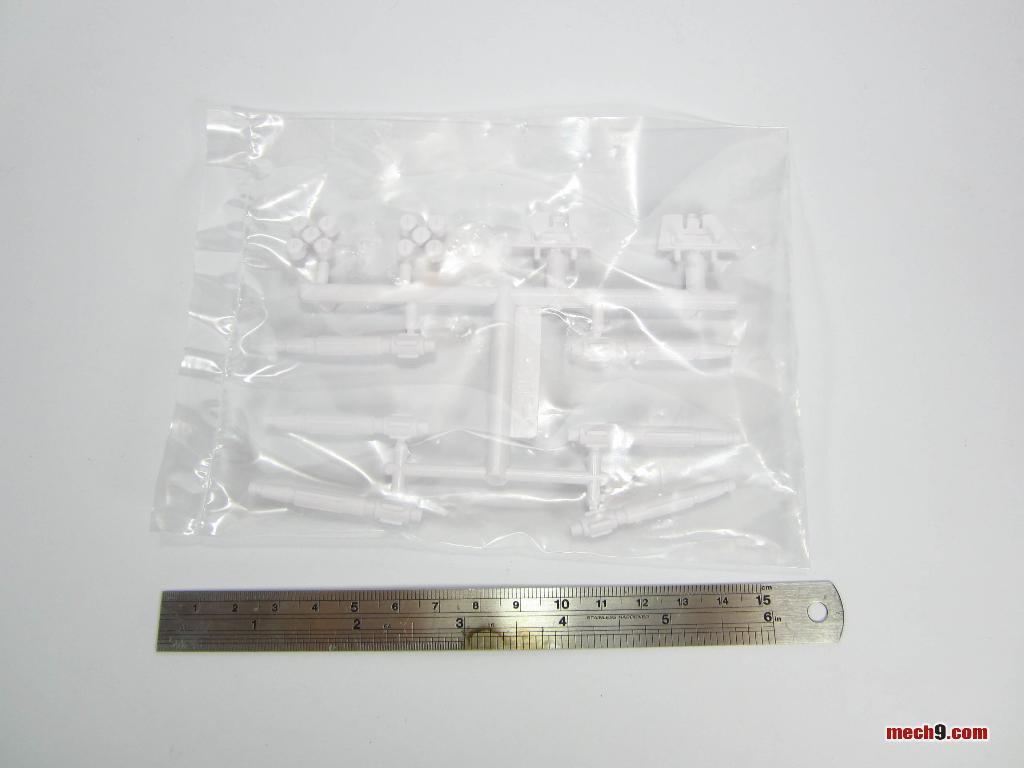<image>
Render a clear and concise summary of the photo. Plastic bag being measured by a ruler with the words mech9 on the bottom. 